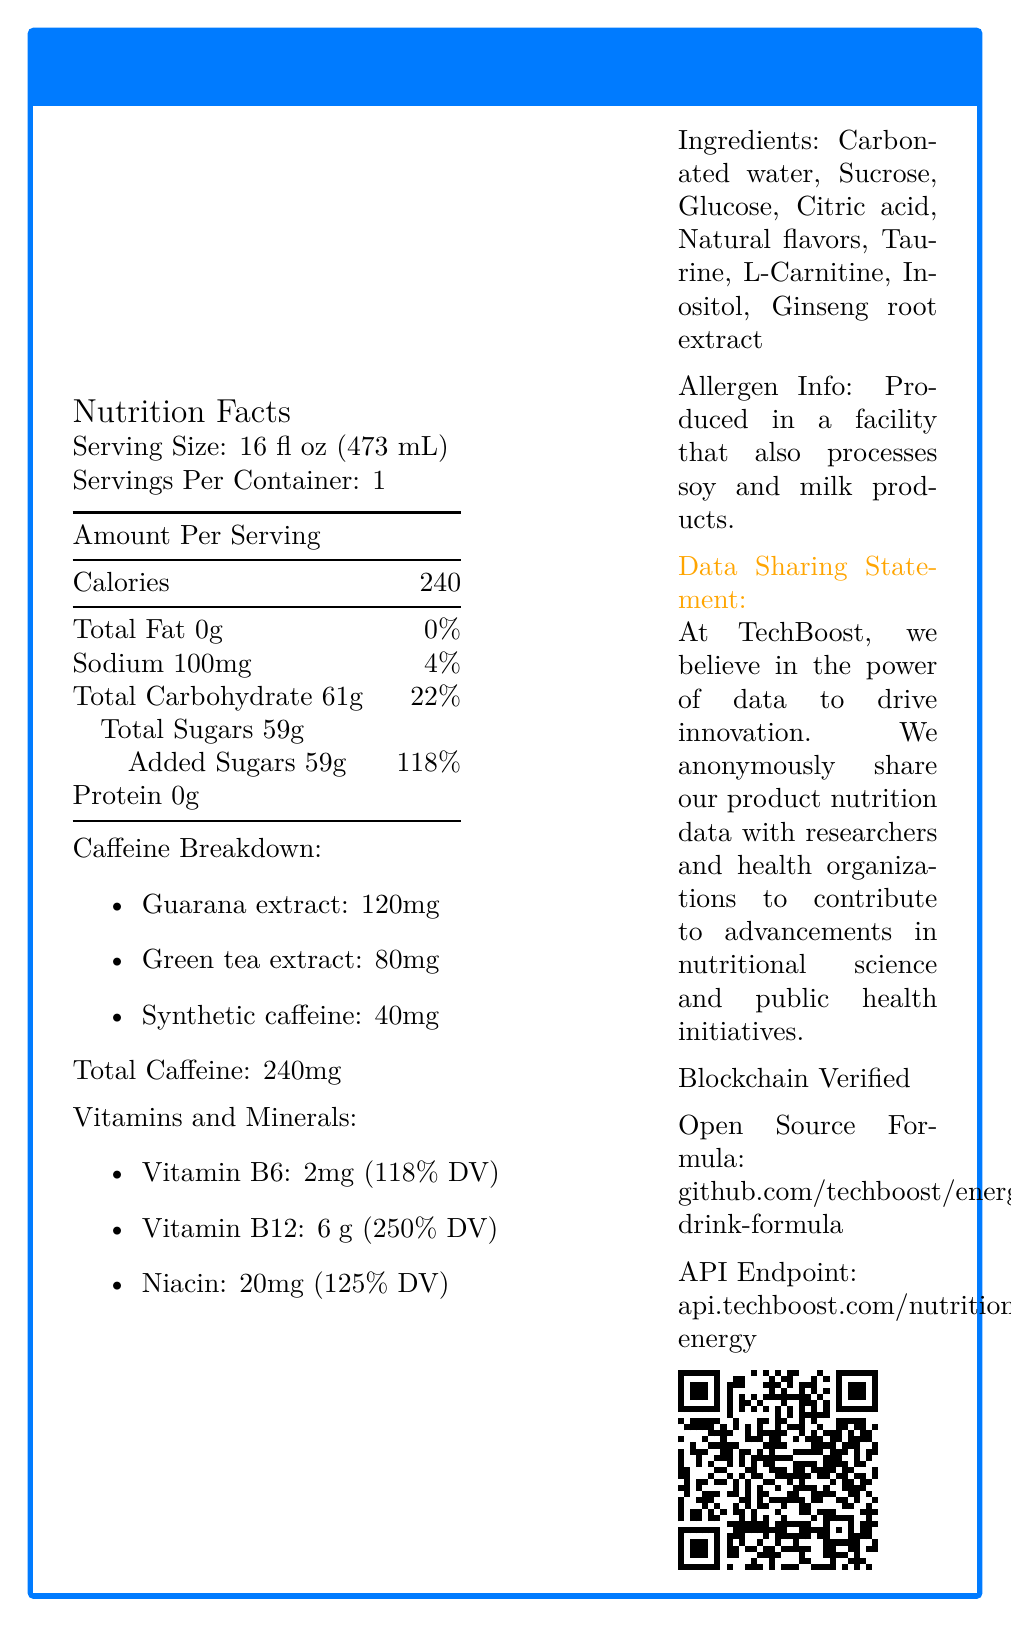what is the serving size for TechBoost Energy? The serving size is clearly mentioned near the top of the Nutrition Facts section.
Answer: 16 fl oz (473 mL) how many calories are there per serving? The document states the amount per serving is 240 calories.
Answer: 240 What is the total amount of caffeine per serving? The total caffeine amount is listed directly under the Caffeine Breakdown section.
Answer: 240mg how much sodium is in one serving? The sodium content per serving is listed as 100mg.
Answer: 100mg What is the percentage of daily value for added sugars? The daily value percentage for added sugars is explicitly stated as 118%.
Answer: 118% which ingredient contributes the most amount of caffeine? A. Guarana extract B. Green tea extract C. Synthetic caffeine Guarana extract contributes 120mg of caffeine, which is the highest among the three listed sources.
Answer: A What is the daily value percentage for Vitamin B12? A. 100% B. 150% C. 200% D. 250% Vitamin B12 provides 250% of the daily value, as listed under the Vitamins and Minerals section.
Answer: D Is TechBoost Energy Blockchain Verified? The document explicitly mentions that TechBoost Energy is blockchain verified.
Answer: Yes Summarize the main features of TechBoost Energy based on the provided Nutrition Facts Label. This comprehensive summary captures the main details from the entire Nutrition Facts Label including nutritional content, ingredients, benefits, and additional features like data sharing and blockchain verification.
Answer: TechBoost Energy is an energy drink with a serving size of 16 fl oz (473 mL) providing 240 calories per serving. It contains no fat, 100mg of sodium, 61g of total carbohydrate, including 59g of sugars, but no protein. The caffeine content per serving totals 240mg, sourced from Guarana extract, Green tea extract, and synthetic caffeine. It also includes several vitamins and minerals such as Vitamin B6, Vitamin B12, and Niacin, contributing significantly to daily value percentages. The drink contains several other ingredients including carbonated water and taurine and is produced in a facility that processes soy and milk products. TechBoost shares its nutrition data for research, is blockchain verified, and has an open-source formula. What kind of flavors are used in TechBoost Energy? The document states that "Natural flavors" are one of the ingredients.
Answer: Natural flavors What is the amount of protein in one serving? The document lists protein content as 0g.
Answer: 0g how much Vitamin B6 is present in one serving? The amount for Vitamin B6 is stated as 2mg in the Vitamins and Minerals section.
Answer: 2mg Which ingredient is not listed in the document but commonly found in other energy drinks? The document provides a list of ingredients, but it isn't possible to determine which commonly found ingredients might be missing without additional information.
Answer: Cannot be determined what is the open source formula URL for TechBoost Energy? The document provides this URL under the Open Source Formula section.
Answer: github.com/techboost/energy-drink-formula 